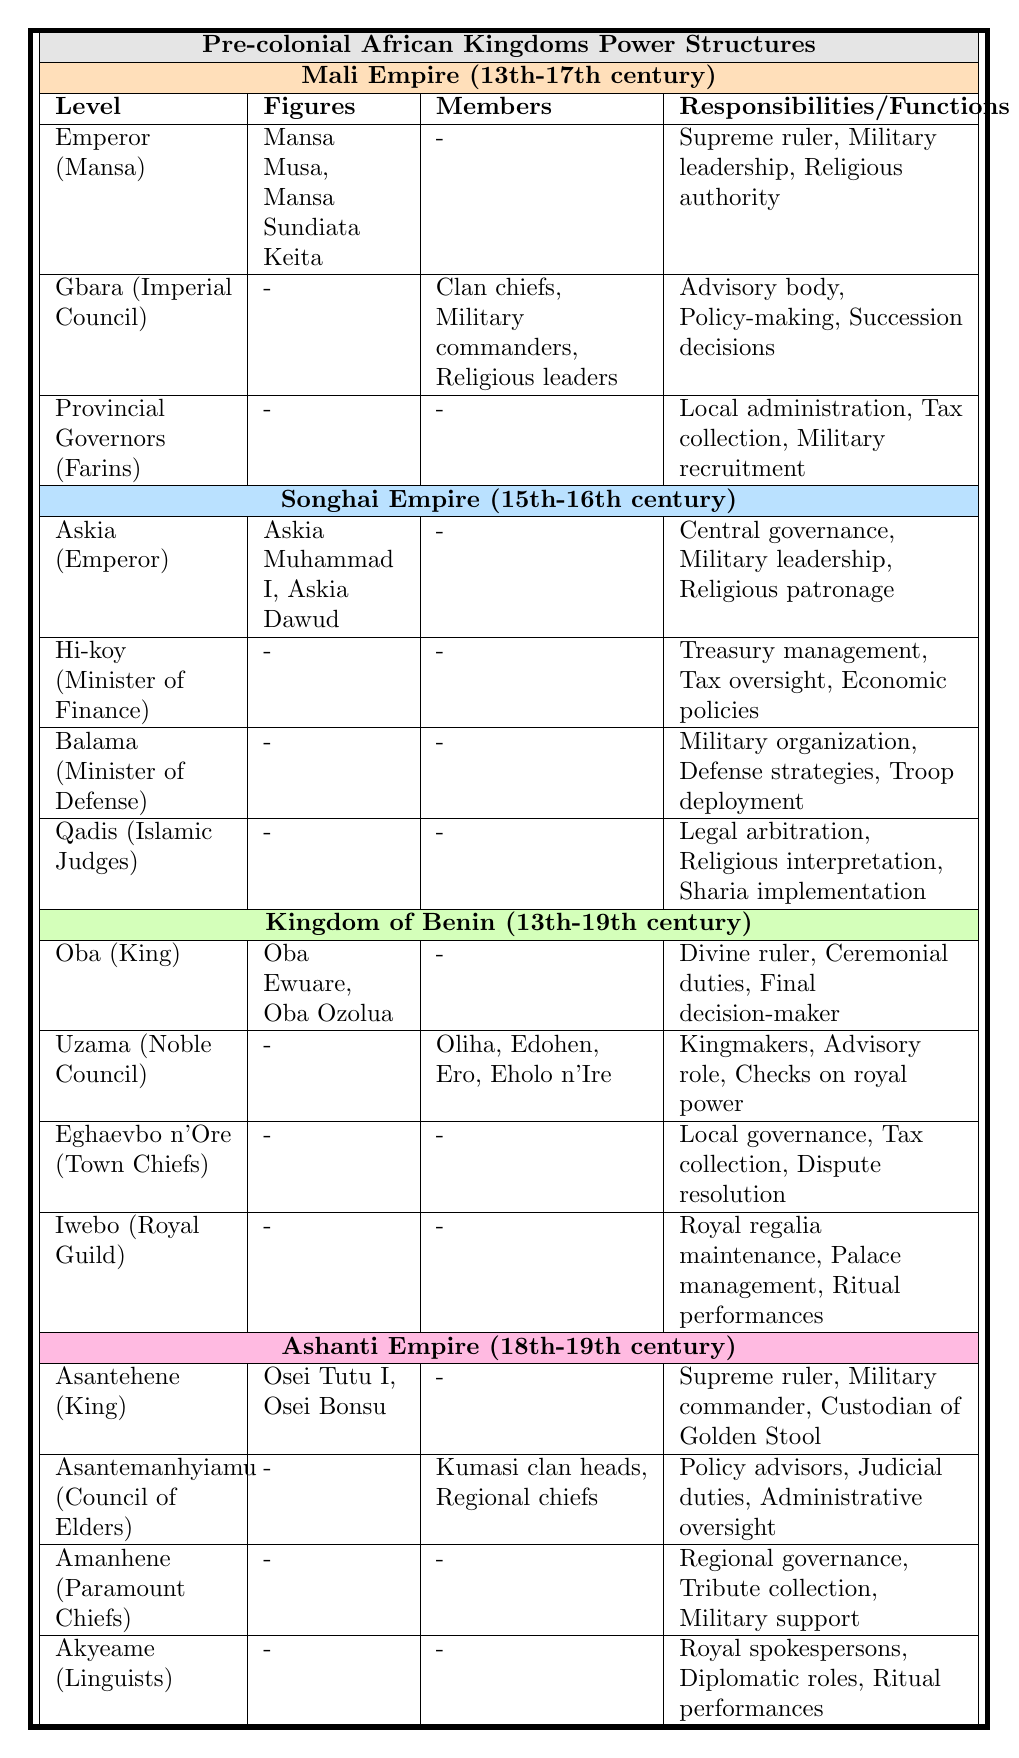What is the time period of the Mali Empire? The table states that the Mali Empire existed from the 13th to the 17th century.
Answer: 13th-17th century Who were the figures associated with the Oba (King) in the Kingdom of Benin? The table lists Oba Ewuare and Oba Ozolua as the figures associated with the Oba in the Kingdom of Benin.
Answer: Oba Ewuare, Oba Ozolua What responsibilities did the Emperor (Mansa) of the Mali Empire have? According to the table, the responsibilities included being the supreme ruler, military leader, and religious authority.
Answer: Supreme ruler, Military leadership, Religious authority How many different levels of power structures are listed for the Songhai Empire? The table shows 4 distinct levels of power structures for the Songhai Empire.
Answer: 4 Is there a Minister of Finance in the Kingdom of Benin? The table does not list a position for Minister of Finance in the Kingdom of Benin, indicating that there is none.
Answer: No Which kingdom had a power structure level called "Amanhene"? The table indicates that the power structure level called "Amanhene" belongs to the Ashanti Empire.
Answer: Ashanti Empire What are the primary functions of the Gbara (Imperial Council) in the Mali Empire? The table specifies that the Gbara serves as an advisory body, engages in policy-making, and makes succession decisions.
Answer: Advisory body, Policy-making, Succession decisions Compare the responsibilities of the Emperor (Mansa) in the Mali Empire with the Askia (Emperor) in the Songhai Empire. The Emperor in the Mali Empire focuses on supreme rule, military leadership, and religious authority, while the Askia in the Songhai Empire also focuses on central governance and religious patronage. Both figures hold key military and religious roles.
Answer: Both hold supreme military and religious roles What type of governance do the Eghaevbo n'Ore (Town Chiefs) in the Kingdom of Benin oversee? The table indicates that the Eghaevbo n'Ore oversee local governance, tax collection, and dispute resolution.
Answer: Local governance, Tax collection, Dispute resolution Which kingdom's power structure had a level called "Akyeame"? The table shows that "Akyeame" is a level in the power structure of the Ashanti Empire.
Answer: Ashanti Empire How many total members are listed in the Uzama (Noble Council) of the Kingdom of Benin? The table lists 4 members in the Uzama: Oliha, Edohen, Ero, and Eholo n'Ire.
Answer: 4 members What was the leading figure in the Ashanti Empire during the 18th century? The table denotes Osei Tutu I as one of the leading figures in the Ashanti Empire during the 18th century.
Answer: Osei Tutu I Which kingdom had a council of elders responsible for policy advising? The Ashanti Empire had a council of elders, known as the Asantemanhyiamu, responsible for advising on policies.
Answer: Ashanti Empire Was the role of legal arbitration part of the Qadis (Islamic Judges) in the Songhai Empire? Yes, the responsibilities of the Qadis explicitly include legal arbitration according to the table.
Answer: Yes What do you conclude about the collective role of the Uzama in the Kingdom of Benin? The Uzama not only act as kingmakers but also hold an advisory role and provide checks on royal power, indicating a significant influence on governance.
Answer: They act as kingmakers and advisors Which kingdom had a power structure that included military defense responsibilities labeled as Balama? The Songhai Empire features a level in its power structure called Balama, responsible for military defense.
Answer: Songhai Empire 